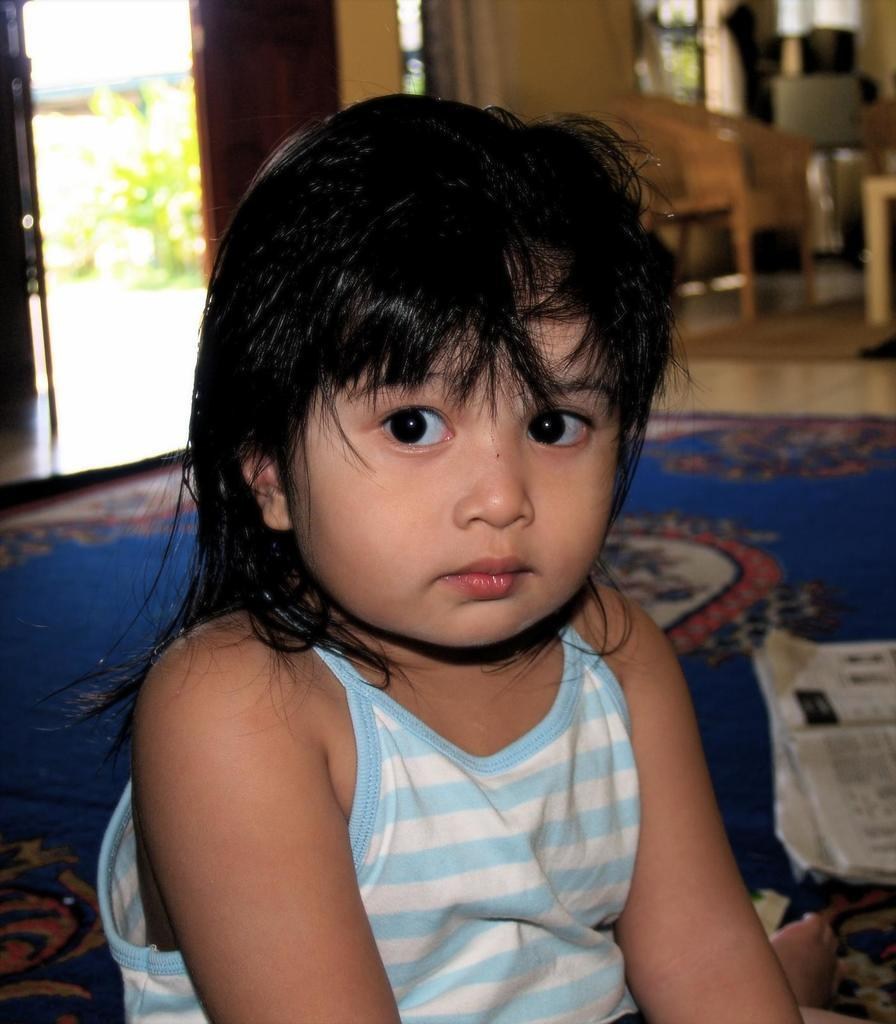What is the main subject in the front of the image? There is a child sitting in the front of the image. What object can be seen in the image that is typically used for reading? There is a newspaper in the image. What is the child sitting on in the image? There is a mat in the image. What type of furniture is present in the image? There are chairs in the image. What architectural feature can be seen in the image? There is a wall in the image. What is another feature of the room that allows access to other areas? There is a door in the image. What type of living organism is present in the image? There is a plant in the image. What type of wave can be seen crashing on the shore in the image? There is no wave or shore present in the image; it features a child, a newspaper, a mat, chairs, a wall, a door, and a plant. 